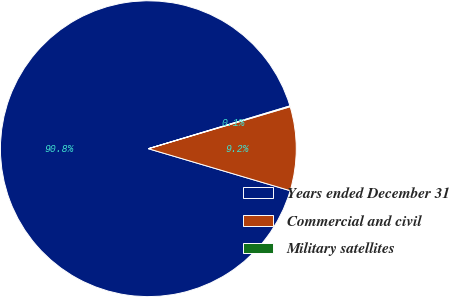Convert chart to OTSL. <chart><loc_0><loc_0><loc_500><loc_500><pie_chart><fcel>Years ended December 31<fcel>Commercial and civil<fcel>Military satellites<nl><fcel>90.75%<fcel>9.16%<fcel>0.09%<nl></chart> 